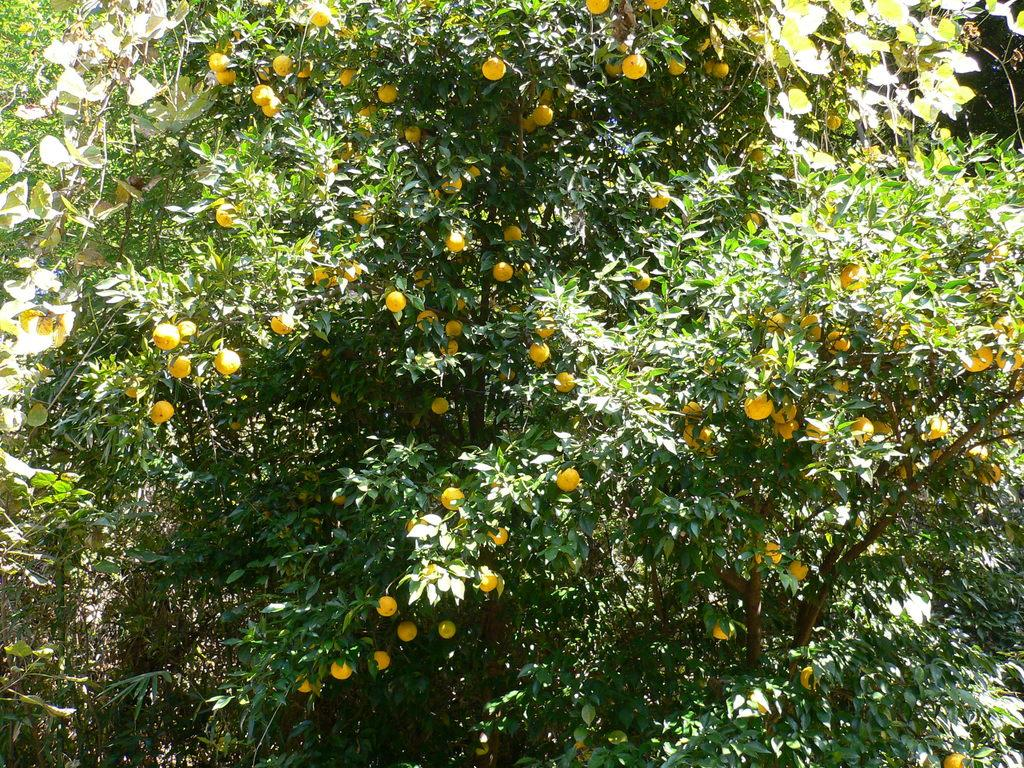What type of fruit is in the foreground of the image? There are there are oranges in the foreground of the image. What can be seen in the background of the image? There are trees visible in the image. Reasoning: Let's think step by step by step in order to produce the conversation. We start by identifying the main subject in the foreground of the image, which is the oranges. Then, we expand the conversation to include the background of the image, which features trees. Each question is designed to elicit a specific detail about the image that is known from the provided facts. Absurd Question/Answer: What type of knot can be seen tied on the wall in the image? There is no wall or knot present in the image; it only features oranges in the foreground and trees in the background. 